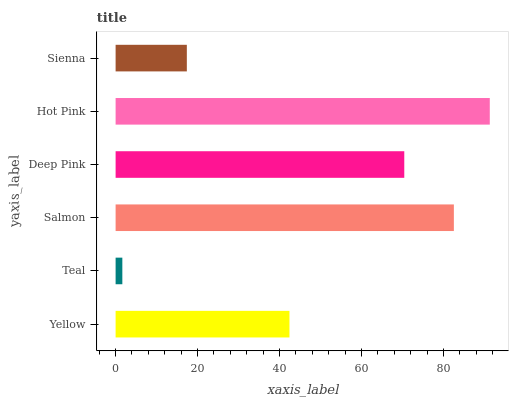Is Teal the minimum?
Answer yes or no. Yes. Is Hot Pink the maximum?
Answer yes or no. Yes. Is Salmon the minimum?
Answer yes or no. No. Is Salmon the maximum?
Answer yes or no. No. Is Salmon greater than Teal?
Answer yes or no. Yes. Is Teal less than Salmon?
Answer yes or no. Yes. Is Teal greater than Salmon?
Answer yes or no. No. Is Salmon less than Teal?
Answer yes or no. No. Is Deep Pink the high median?
Answer yes or no. Yes. Is Yellow the low median?
Answer yes or no. Yes. Is Teal the high median?
Answer yes or no. No. Is Teal the low median?
Answer yes or no. No. 